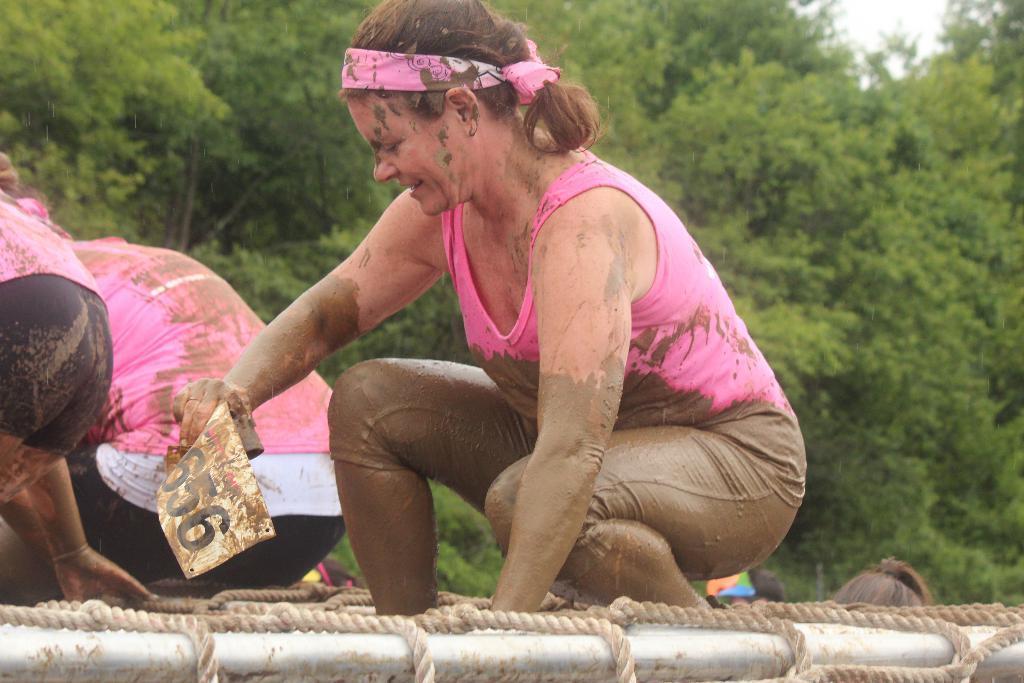In one or two sentences, can you explain what this image depicts? In this picture I can see a woman holding a paper in her hand and I can see mud on her body and I can see couple of them on the side and I can see ropes to the metal rods and trees. 